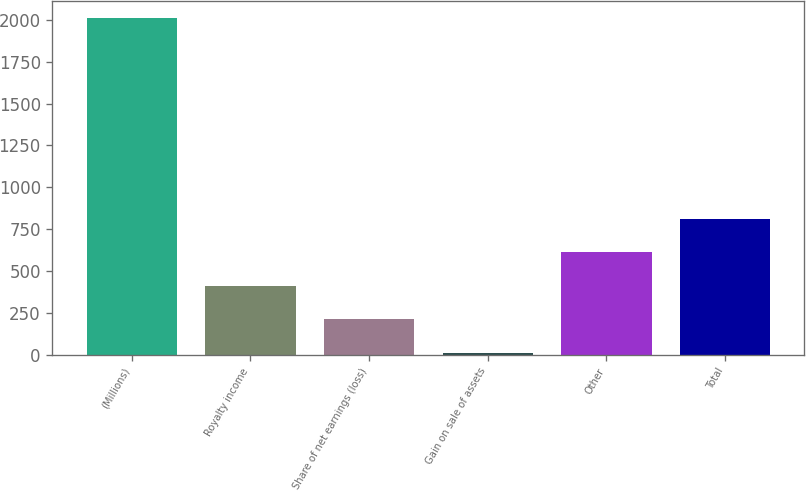Convert chart. <chart><loc_0><loc_0><loc_500><loc_500><bar_chart><fcel>(Millions)<fcel>Royalty income<fcel>Share of net earnings (loss)<fcel>Gain on sale of assets<fcel>Other<fcel>Total<nl><fcel>2011<fcel>411.8<fcel>211.9<fcel>12<fcel>611.7<fcel>811.6<nl></chart> 